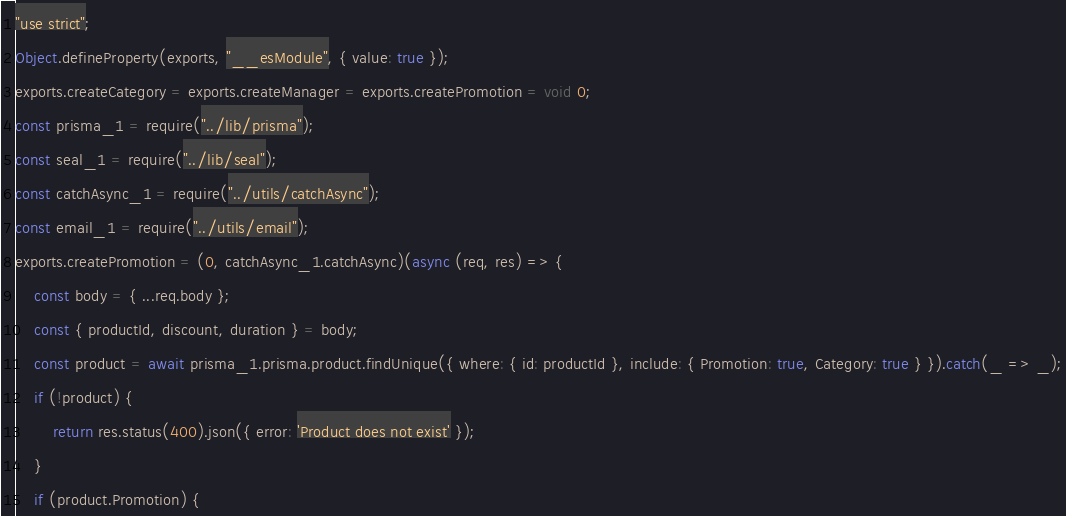Convert code to text. <code><loc_0><loc_0><loc_500><loc_500><_JavaScript_>"use strict";
Object.defineProperty(exports, "__esModule", { value: true });
exports.createCategory = exports.createManager = exports.createPromotion = void 0;
const prisma_1 = require("../lib/prisma");
const seal_1 = require("../lib/seal");
const catchAsync_1 = require("../utils/catchAsync");
const email_1 = require("../utils/email");
exports.createPromotion = (0, catchAsync_1.catchAsync)(async (req, res) => {
    const body = { ...req.body };
    const { productId, discount, duration } = body;
    const product = await prisma_1.prisma.product.findUnique({ where: { id: productId }, include: { Promotion: true, Category: true } }).catch(_ => _);
    if (!product) {
        return res.status(400).json({ error: 'Product does not exist' });
    }
    if (product.Promotion) {</code> 